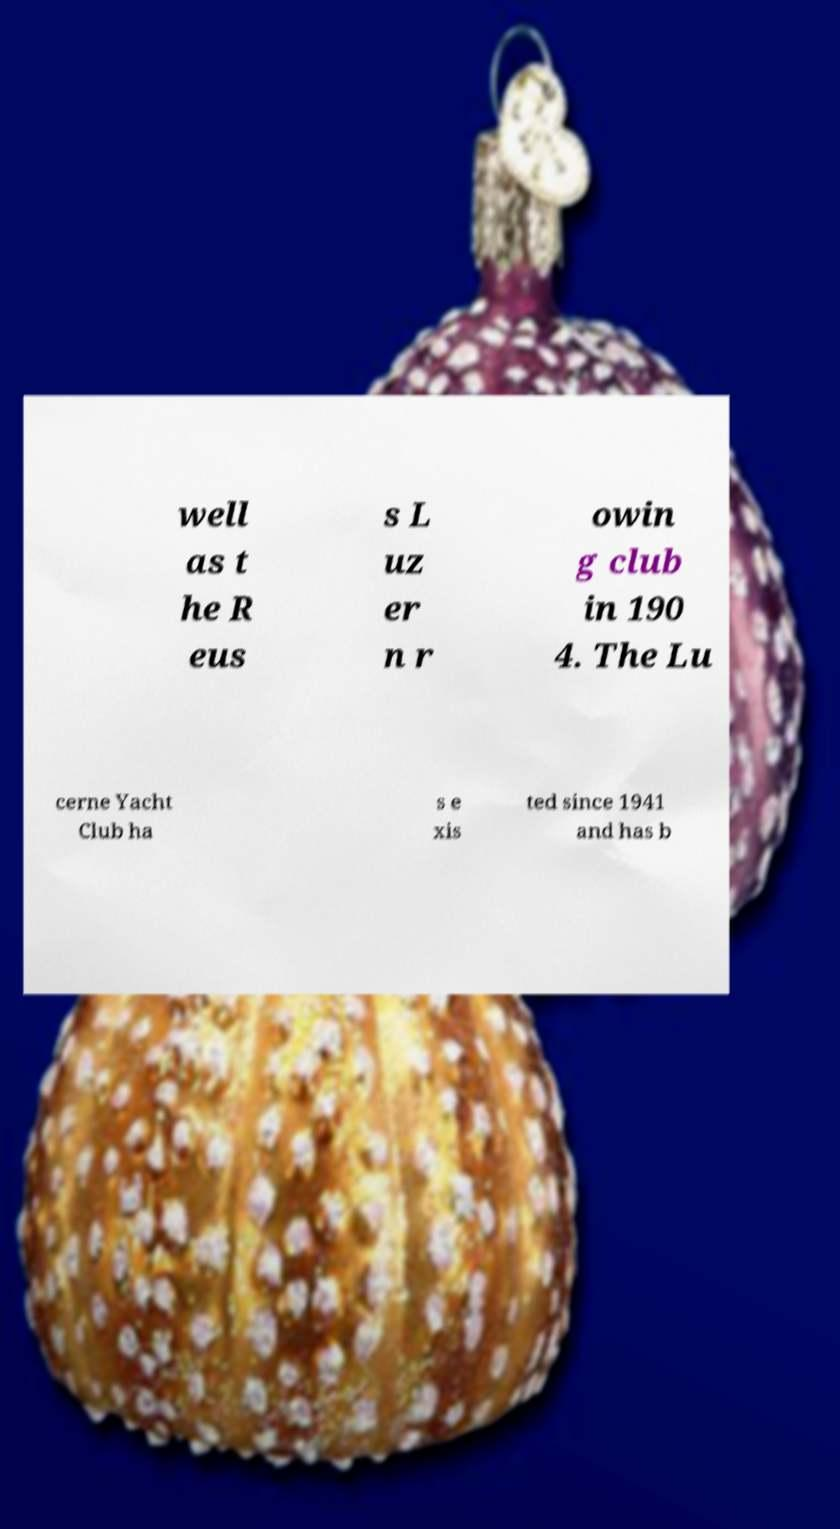Please identify and transcribe the text found in this image. well as t he R eus s L uz er n r owin g club in 190 4. The Lu cerne Yacht Club ha s e xis ted since 1941 and has b 